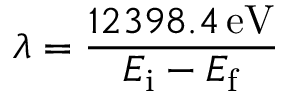<formula> <loc_0><loc_0><loc_500><loc_500>\lambda = { \frac { 1 2 3 9 8 . 4 \, { e V } } { E _ { i } - E _ { f } } }</formula> 